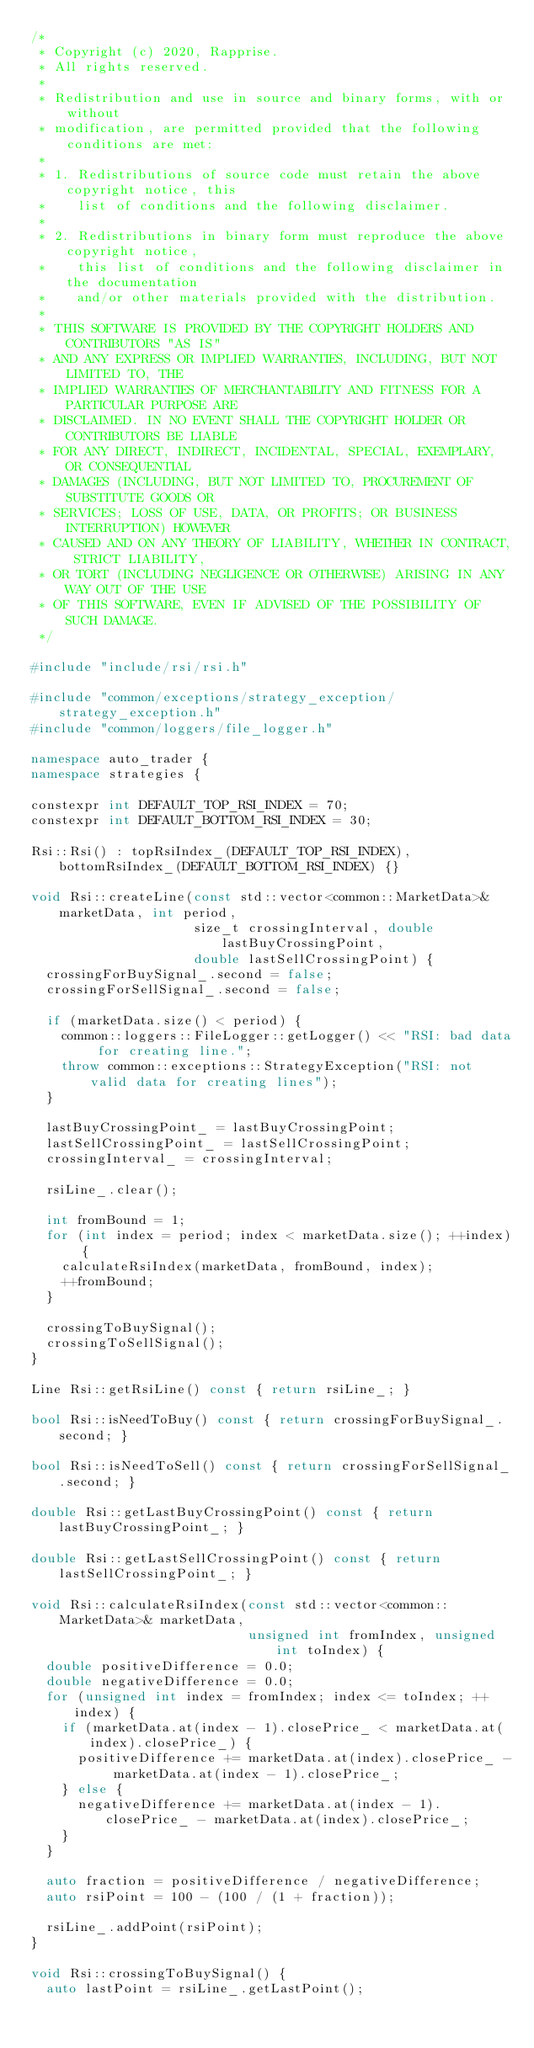<code> <loc_0><loc_0><loc_500><loc_500><_C++_>/*
 * Copyright (c) 2020, Rapprise.
 * All rights reserved.
 *
 * Redistribution and use in source and binary forms, with or without
 * modification, are permitted provided that the following conditions are met:
 *
 * 1. Redistributions of source code must retain the above copyright notice, this
 *    list of conditions and the following disclaimer.
 *
 * 2. Redistributions in binary form must reproduce the above copyright notice,
 *    this list of conditions and the following disclaimer in the documentation
 *    and/or other materials provided with the distribution.
 *
 * THIS SOFTWARE IS PROVIDED BY THE COPYRIGHT HOLDERS AND CONTRIBUTORS "AS IS"
 * AND ANY EXPRESS OR IMPLIED WARRANTIES, INCLUDING, BUT NOT LIMITED TO, THE
 * IMPLIED WARRANTIES OF MERCHANTABILITY AND FITNESS FOR A PARTICULAR PURPOSE ARE
 * DISCLAIMED. IN NO EVENT SHALL THE COPYRIGHT HOLDER OR CONTRIBUTORS BE LIABLE
 * FOR ANY DIRECT, INDIRECT, INCIDENTAL, SPECIAL, EXEMPLARY, OR CONSEQUENTIAL
 * DAMAGES (INCLUDING, BUT NOT LIMITED TO, PROCUREMENT OF SUBSTITUTE GOODS OR
 * SERVICES; LOSS OF USE, DATA, OR PROFITS; OR BUSINESS INTERRUPTION) HOWEVER
 * CAUSED AND ON ANY THEORY OF LIABILITY, WHETHER IN CONTRACT, STRICT LIABILITY,
 * OR TORT (INCLUDING NEGLIGENCE OR OTHERWISE) ARISING IN ANY WAY OUT OF THE USE
 * OF THIS SOFTWARE, EVEN IF ADVISED OF THE POSSIBILITY OF SUCH DAMAGE.
 */

#include "include/rsi/rsi.h"

#include "common/exceptions/strategy_exception/strategy_exception.h"
#include "common/loggers/file_logger.h"

namespace auto_trader {
namespace strategies {

constexpr int DEFAULT_TOP_RSI_INDEX = 70;
constexpr int DEFAULT_BOTTOM_RSI_INDEX = 30;

Rsi::Rsi() : topRsiIndex_(DEFAULT_TOP_RSI_INDEX), bottomRsiIndex_(DEFAULT_BOTTOM_RSI_INDEX) {}

void Rsi::createLine(const std::vector<common::MarketData>& marketData, int period,
                     size_t crossingInterval, double lastBuyCrossingPoint,
                     double lastSellCrossingPoint) {
  crossingForBuySignal_.second = false;
  crossingForSellSignal_.second = false;

  if (marketData.size() < period) {
    common::loggers::FileLogger::getLogger() << "RSI: bad data for creating line.";
    throw common::exceptions::StrategyException("RSI: not valid data for creating lines");
  }

  lastBuyCrossingPoint_ = lastBuyCrossingPoint;
  lastSellCrossingPoint_ = lastSellCrossingPoint;
  crossingInterval_ = crossingInterval;

  rsiLine_.clear();

  int fromBound = 1;
  for (int index = period; index < marketData.size(); ++index) {
    calculateRsiIndex(marketData, fromBound, index);
    ++fromBound;
  }

  crossingToBuySignal();
  crossingToSellSignal();
}

Line Rsi::getRsiLine() const { return rsiLine_; }

bool Rsi::isNeedToBuy() const { return crossingForBuySignal_.second; }

bool Rsi::isNeedToSell() const { return crossingForSellSignal_.second; }

double Rsi::getLastBuyCrossingPoint() const { return lastBuyCrossingPoint_; }

double Rsi::getLastSellCrossingPoint() const { return lastSellCrossingPoint_; }

void Rsi::calculateRsiIndex(const std::vector<common::MarketData>& marketData,
                            unsigned int fromIndex, unsigned int toIndex) {
  double positiveDifference = 0.0;
  double negativeDifference = 0.0;
  for (unsigned int index = fromIndex; index <= toIndex; ++index) {
    if (marketData.at(index - 1).closePrice_ < marketData.at(index).closePrice_) {
      positiveDifference += marketData.at(index).closePrice_ - marketData.at(index - 1).closePrice_;
    } else {
      negativeDifference += marketData.at(index - 1).closePrice_ - marketData.at(index).closePrice_;
    }
  }

  auto fraction = positiveDifference / negativeDifference;
  auto rsiPoint = 100 - (100 / (1 + fraction));

  rsiLine_.addPoint(rsiPoint);
}

void Rsi::crossingToBuySignal() {
  auto lastPoint = rsiLine_.getLastPoint();</code> 